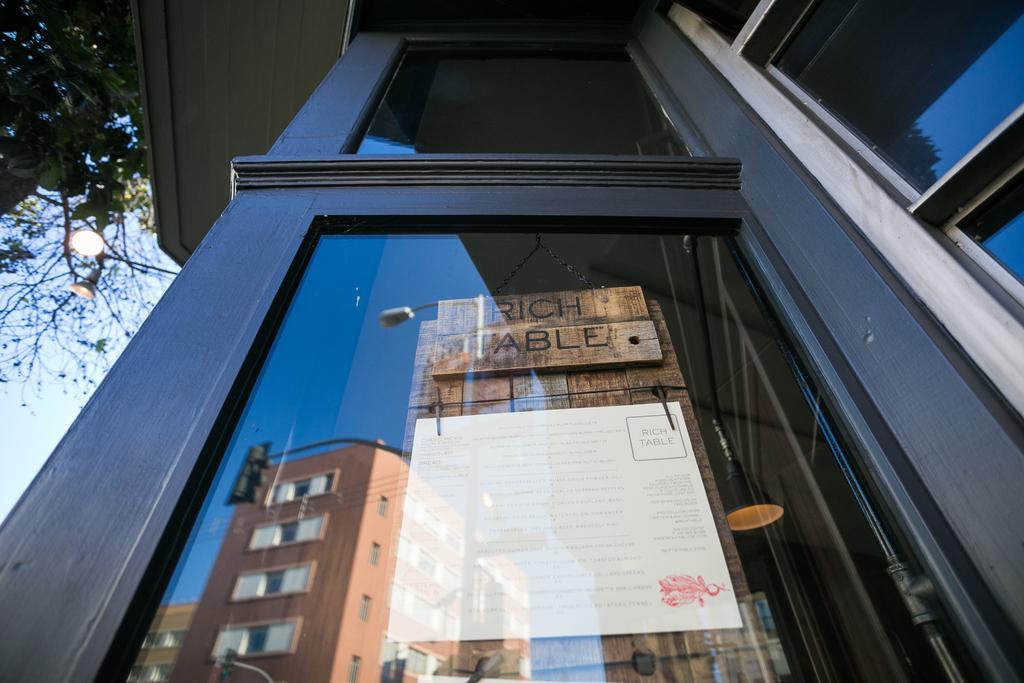Describe this image in one or two sentences. In this image we can see trees, lights, there are windows, we can see a board through the window, it has text on it, also we can see the reflections of buildings, traffic lights, and light pole on the window mirror, also we can see the light. 